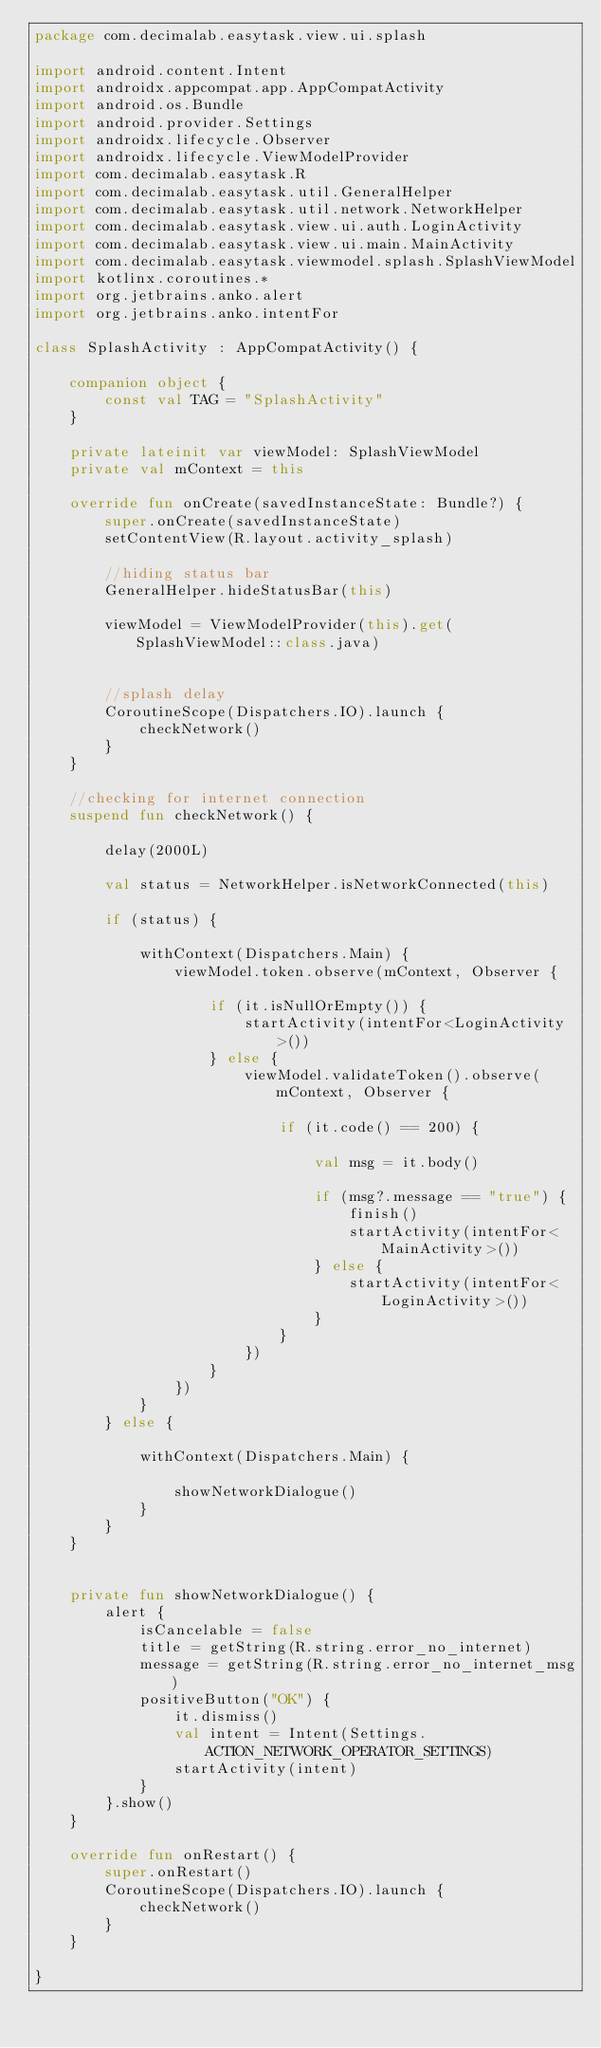<code> <loc_0><loc_0><loc_500><loc_500><_Kotlin_>package com.decimalab.easytask.view.ui.splash

import android.content.Intent
import androidx.appcompat.app.AppCompatActivity
import android.os.Bundle
import android.provider.Settings
import androidx.lifecycle.Observer
import androidx.lifecycle.ViewModelProvider
import com.decimalab.easytask.R
import com.decimalab.easytask.util.GeneralHelper
import com.decimalab.easytask.util.network.NetworkHelper
import com.decimalab.easytask.view.ui.auth.LoginActivity
import com.decimalab.easytask.view.ui.main.MainActivity
import com.decimalab.easytask.viewmodel.splash.SplashViewModel
import kotlinx.coroutines.*
import org.jetbrains.anko.alert
import org.jetbrains.anko.intentFor

class SplashActivity : AppCompatActivity() {

    companion object {
        const val TAG = "SplashActivity"
    }

    private lateinit var viewModel: SplashViewModel
    private val mContext = this

    override fun onCreate(savedInstanceState: Bundle?) {
        super.onCreate(savedInstanceState)
        setContentView(R.layout.activity_splash)

        //hiding status bar
        GeneralHelper.hideStatusBar(this)

        viewModel = ViewModelProvider(this).get(SplashViewModel::class.java)


        //splash delay
        CoroutineScope(Dispatchers.IO).launch {
            checkNetwork()
        }
    }

    //checking for internet connection
    suspend fun checkNetwork() {

        delay(2000L)

        val status = NetworkHelper.isNetworkConnected(this)

        if (status) {

            withContext(Dispatchers.Main) {
                viewModel.token.observe(mContext, Observer {

                    if (it.isNullOrEmpty()) {
                        startActivity(intentFor<LoginActivity>())
                    } else {
                        viewModel.validateToken().observe(mContext, Observer {

                            if (it.code() == 200) {

                                val msg = it.body()

                                if (msg?.message == "true") {
                                    finish()
                                    startActivity(intentFor<MainActivity>())
                                } else {
                                    startActivity(intentFor<LoginActivity>())
                                }
                            }
                        })
                    }
                })
            }
        } else {

            withContext(Dispatchers.Main) {

                showNetworkDialogue()
            }
        }
    }


    private fun showNetworkDialogue() {
        alert {
            isCancelable = false
            title = getString(R.string.error_no_internet)
            message = getString(R.string.error_no_internet_msg)
            positiveButton("OK") {
                it.dismiss()
                val intent = Intent(Settings.ACTION_NETWORK_OPERATOR_SETTINGS)
                startActivity(intent)
            }
        }.show()
    }

    override fun onRestart() {
        super.onRestart()
        CoroutineScope(Dispatchers.IO).launch {
            checkNetwork()
        }
    }

}
</code> 